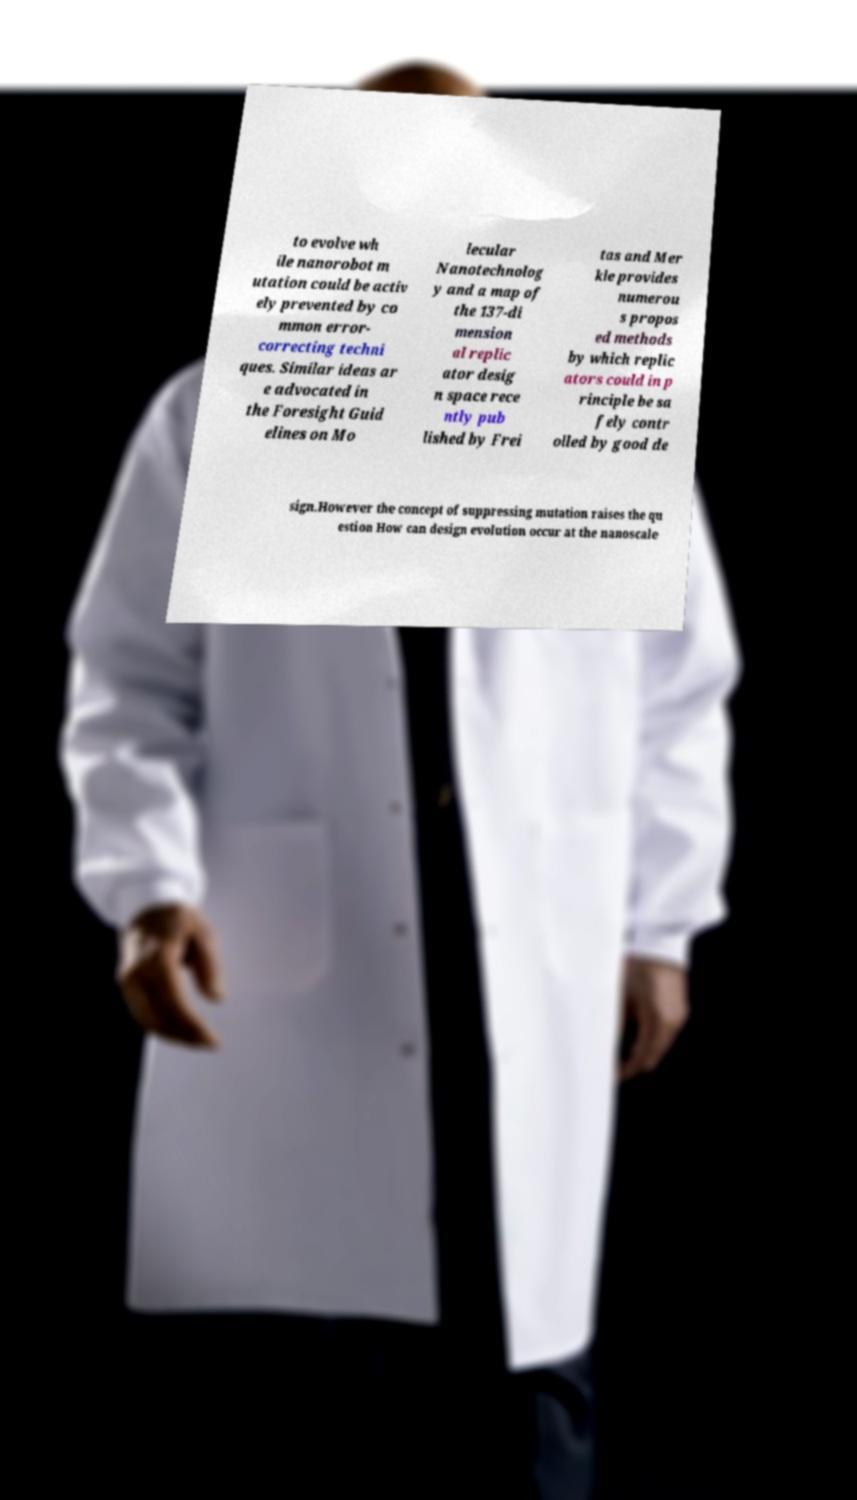Please read and relay the text visible in this image. What does it say? to evolve wh ile nanorobot m utation could be activ ely prevented by co mmon error- correcting techni ques. Similar ideas ar e advocated in the Foresight Guid elines on Mo lecular Nanotechnolog y and a map of the 137-di mension al replic ator desig n space rece ntly pub lished by Frei tas and Mer kle provides numerou s propos ed methods by which replic ators could in p rinciple be sa fely contr olled by good de sign.However the concept of suppressing mutation raises the qu estion How can design evolution occur at the nanoscale 